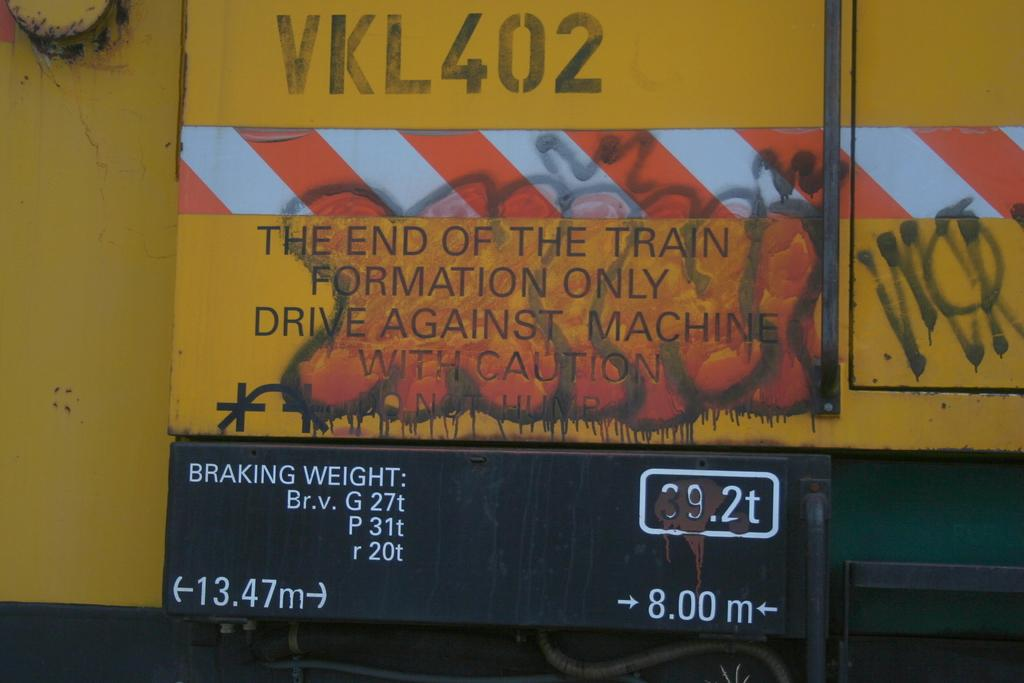<image>
Describe the image concisely. Sign on the back of a bus that says "The end of the train formation only". 